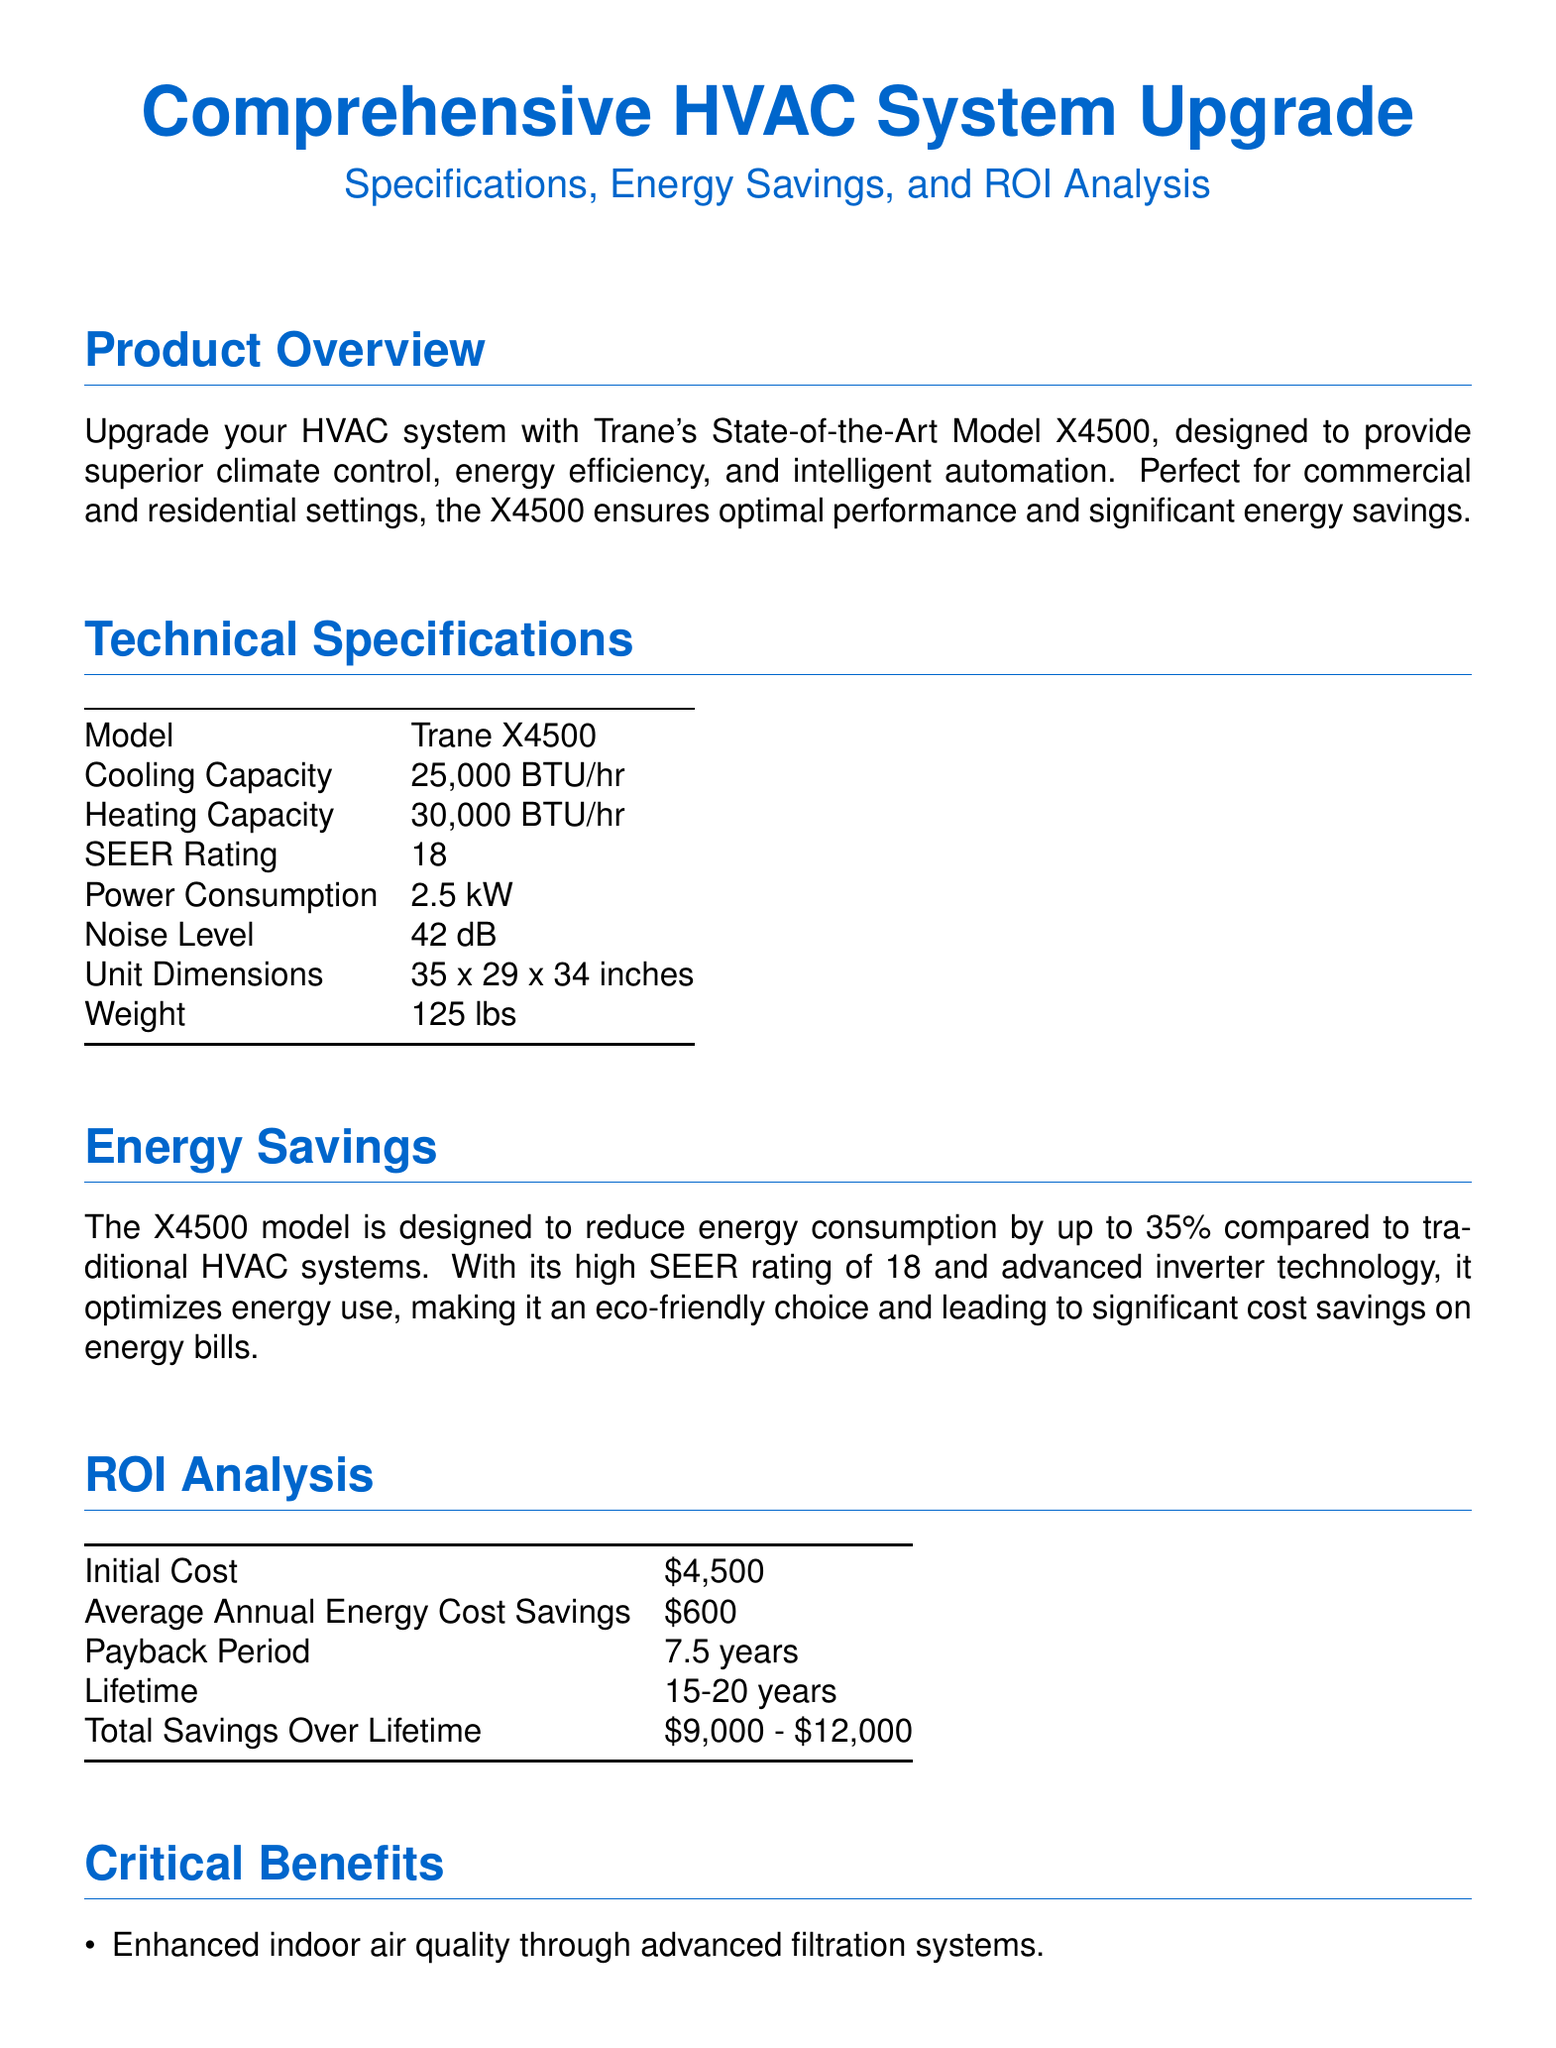What is the model of the HVAC system? The model of the HVAC system is specified in the technical specifications section as Trane X4500.
Answer: Trane X4500 What is the SEER rating of the Trane X4500? The SEER rating is provided in the technical specifications table, which indicates a rating of 18.
Answer: 18 What is the payback period for the HVAC system? The payback period is mentioned in the ROI analysis section as being 7.5 years.
Answer: 7.5 years How much can the X4500 reduce energy consumption by? The energy savings section states that the model can reduce energy consumption by up to 35%.
Answer: 35% What is the initial cost of the HVAC system? The initial cost is listed in the ROI analysis table and is $4,500.
Answer: $4,500 What are the total savings over the lifetime of the system? The total savings over a lifetime is specified in the ROI analysis as ranging from $9,000 to $12,000.
Answer: $9,000 - $12,000 What is the cooling capacity of the Trane X4500? The cooling capacity is provided in the technical specifications section as 25,000 BTU/hr.
Answer: 25,000 BTU/hr What type of operation is characterized by the unit's noise level? The noise level of the unit is described in the technical specifications as being 42 dB, indicating quiet operation.
Answer: 42 dB Which feature enhances indoor air quality for the HVAC system? The critical benefits highlighted an advanced filtration system as a feature that enhances indoor air quality.
Answer: Advanced filtration systems 